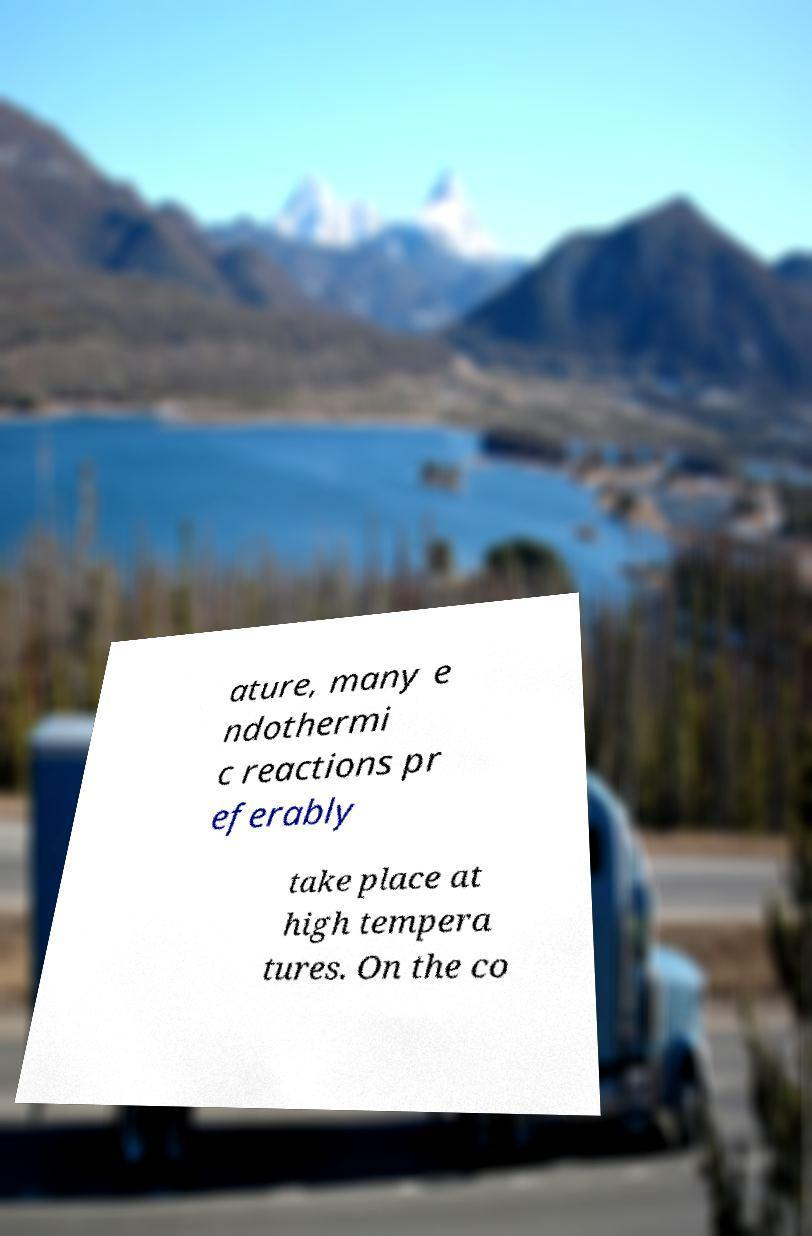Can you accurately transcribe the text from the provided image for me? ature, many e ndothermi c reactions pr eferably take place at high tempera tures. On the co 